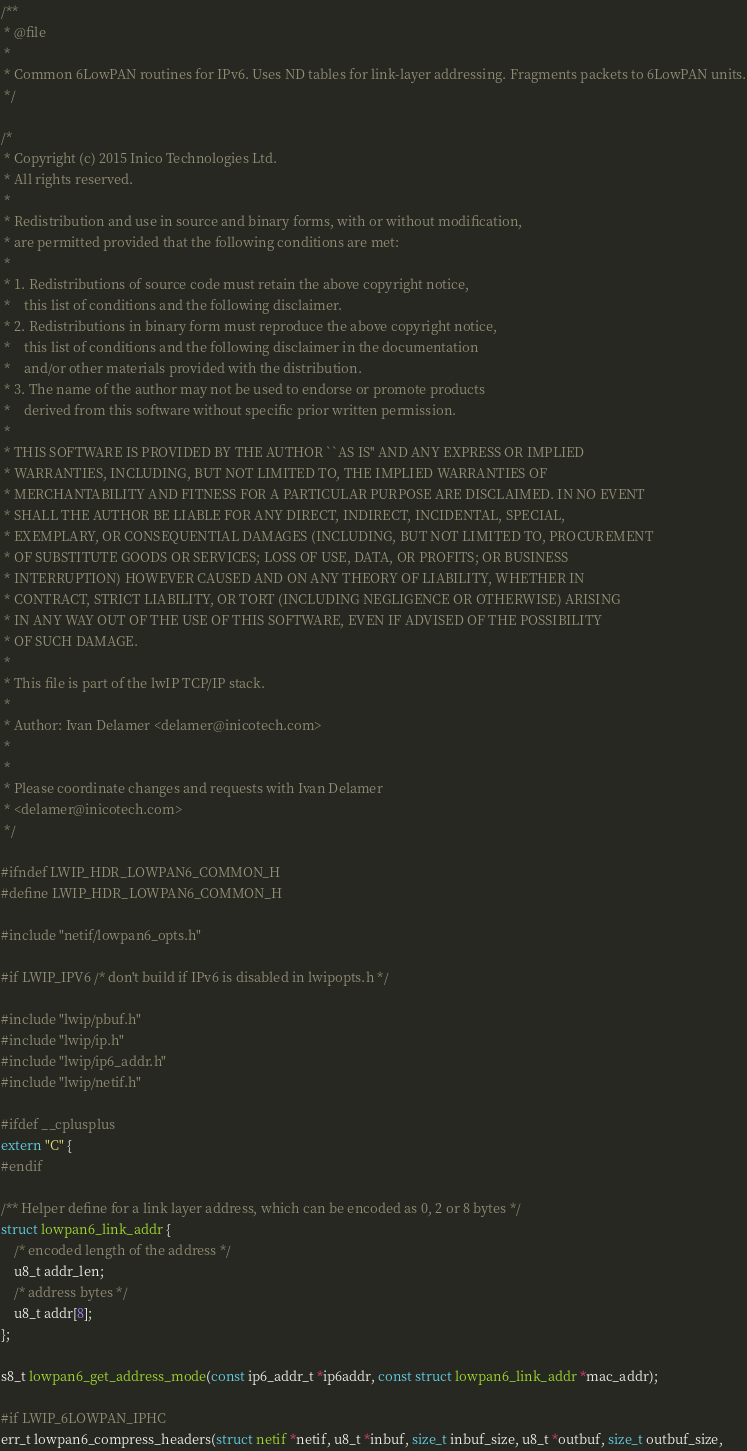<code> <loc_0><loc_0><loc_500><loc_500><_C_>/**
 * @file
 *
 * Common 6LowPAN routines for IPv6. Uses ND tables for link-layer addressing. Fragments packets to 6LowPAN units.
 */

/*
 * Copyright (c) 2015 Inico Technologies Ltd.
 * All rights reserved.
 *
 * Redistribution and use in source and binary forms, with or without modification,
 * are permitted provided that the following conditions are met:
 *
 * 1. Redistributions of source code must retain the above copyright notice,
 *    this list of conditions and the following disclaimer.
 * 2. Redistributions in binary form must reproduce the above copyright notice,
 *    this list of conditions and the following disclaimer in the documentation
 *    and/or other materials provided with the distribution.
 * 3. The name of the author may not be used to endorse or promote products
 *    derived from this software without specific prior written permission.
 *
 * THIS SOFTWARE IS PROVIDED BY THE AUTHOR ``AS IS'' AND ANY EXPRESS OR IMPLIED
 * WARRANTIES, INCLUDING, BUT NOT LIMITED TO, THE IMPLIED WARRANTIES OF
 * MERCHANTABILITY AND FITNESS FOR A PARTICULAR PURPOSE ARE DISCLAIMED. IN NO EVENT
 * SHALL THE AUTHOR BE LIABLE FOR ANY DIRECT, INDIRECT, INCIDENTAL, SPECIAL,
 * EXEMPLARY, OR CONSEQUENTIAL DAMAGES (INCLUDING, BUT NOT LIMITED TO, PROCUREMENT
 * OF SUBSTITUTE GOODS OR SERVICES; LOSS OF USE, DATA, OR PROFITS; OR BUSINESS
 * INTERRUPTION) HOWEVER CAUSED AND ON ANY THEORY OF LIABILITY, WHETHER IN
 * CONTRACT, STRICT LIABILITY, OR TORT (INCLUDING NEGLIGENCE OR OTHERWISE) ARISING
 * IN ANY WAY OUT OF THE USE OF THIS SOFTWARE, EVEN IF ADVISED OF THE POSSIBILITY
 * OF SUCH DAMAGE.
 *
 * This file is part of the lwIP TCP/IP stack.
 *
 * Author: Ivan Delamer <delamer@inicotech.com>
 *
 *
 * Please coordinate changes and requests with Ivan Delamer
 * <delamer@inicotech.com>
 */

#ifndef LWIP_HDR_LOWPAN6_COMMON_H
#define LWIP_HDR_LOWPAN6_COMMON_H

#include "netif/lowpan6_opts.h"

#if LWIP_IPV6 /* don't build if IPv6 is disabled in lwipopts.h */

#include "lwip/pbuf.h"
#include "lwip/ip.h"
#include "lwip/ip6_addr.h"
#include "lwip/netif.h"

#ifdef __cplusplus
extern "C" {
#endif

/** Helper define for a link layer address, which can be encoded as 0, 2 or 8 bytes */
struct lowpan6_link_addr {
    /* encoded length of the address */
    u8_t addr_len;
    /* address bytes */
    u8_t addr[8];
};

s8_t lowpan6_get_address_mode(const ip6_addr_t *ip6addr, const struct lowpan6_link_addr *mac_addr);

#if LWIP_6LOWPAN_IPHC
err_t lowpan6_compress_headers(struct netif *netif, u8_t *inbuf, size_t inbuf_size, u8_t *outbuf, size_t outbuf_size,</code> 